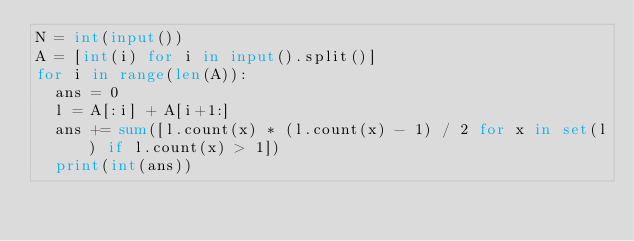Convert code to text. <code><loc_0><loc_0><loc_500><loc_500><_Python_>N = int(input())
A = [int(i) for i in input().split()]
for i in range(len(A)):
  ans = 0
  l = A[:i] + A[i+1:]
  ans += sum([l.count(x) * (l.count(x) - 1) / 2 for x in set(l) if l.count(x) > 1])
  print(int(ans))</code> 